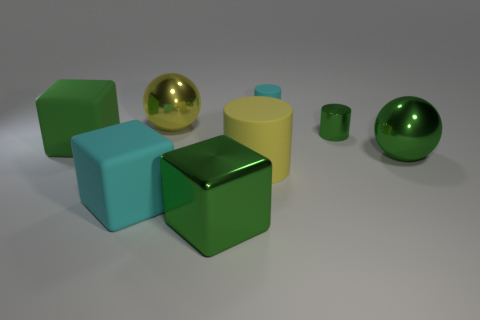Add 1 big gray metallic objects. How many objects exist? 9 Subtract all cylinders. How many objects are left? 5 Add 2 spheres. How many spheres are left? 4 Add 4 big metal balls. How many big metal balls exist? 6 Subtract 1 cyan blocks. How many objects are left? 7 Subtract all large rubber spheres. Subtract all large blocks. How many objects are left? 5 